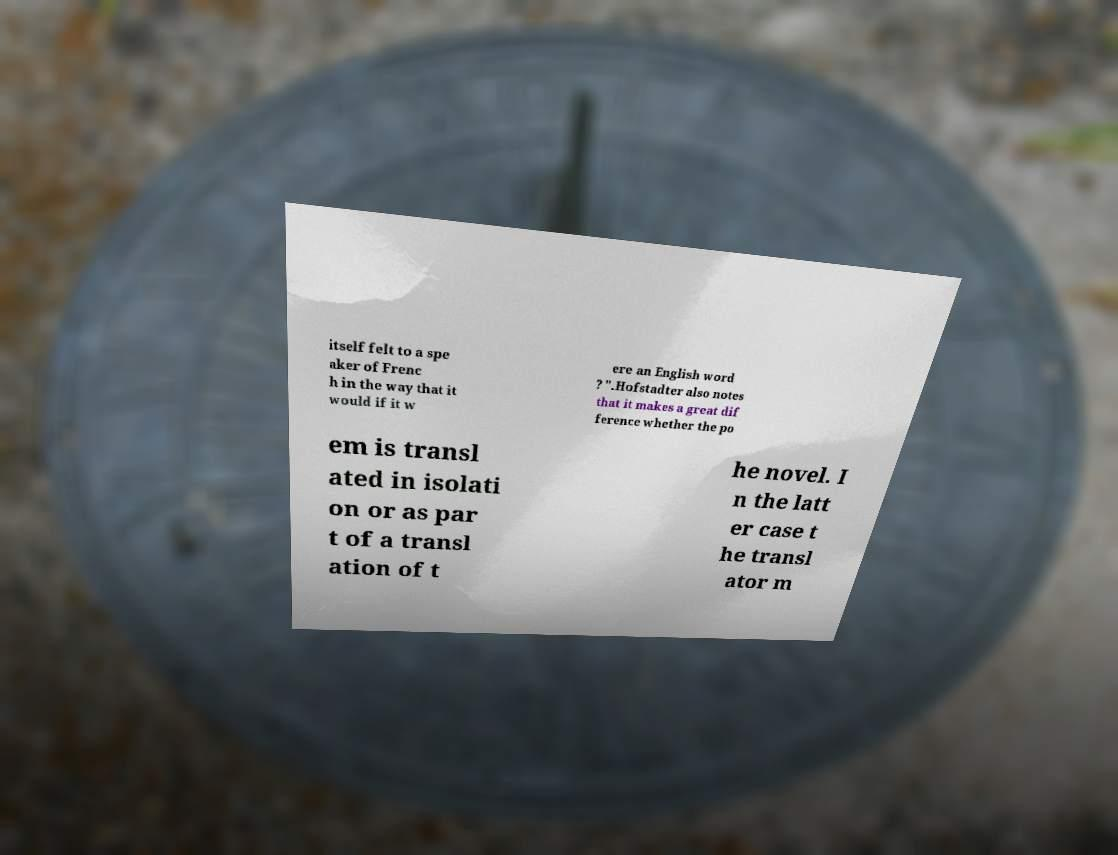Can you read and provide the text displayed in the image?This photo seems to have some interesting text. Can you extract and type it out for me? itself felt to a spe aker of Frenc h in the way that it would if it w ere an English word ? ".Hofstadter also notes that it makes a great dif ference whether the po em is transl ated in isolati on or as par t of a transl ation of t he novel. I n the latt er case t he transl ator m 